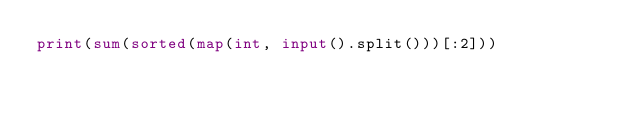Convert code to text. <code><loc_0><loc_0><loc_500><loc_500><_Python_>print(sum(sorted(map(int, input().split()))[:2]))</code> 